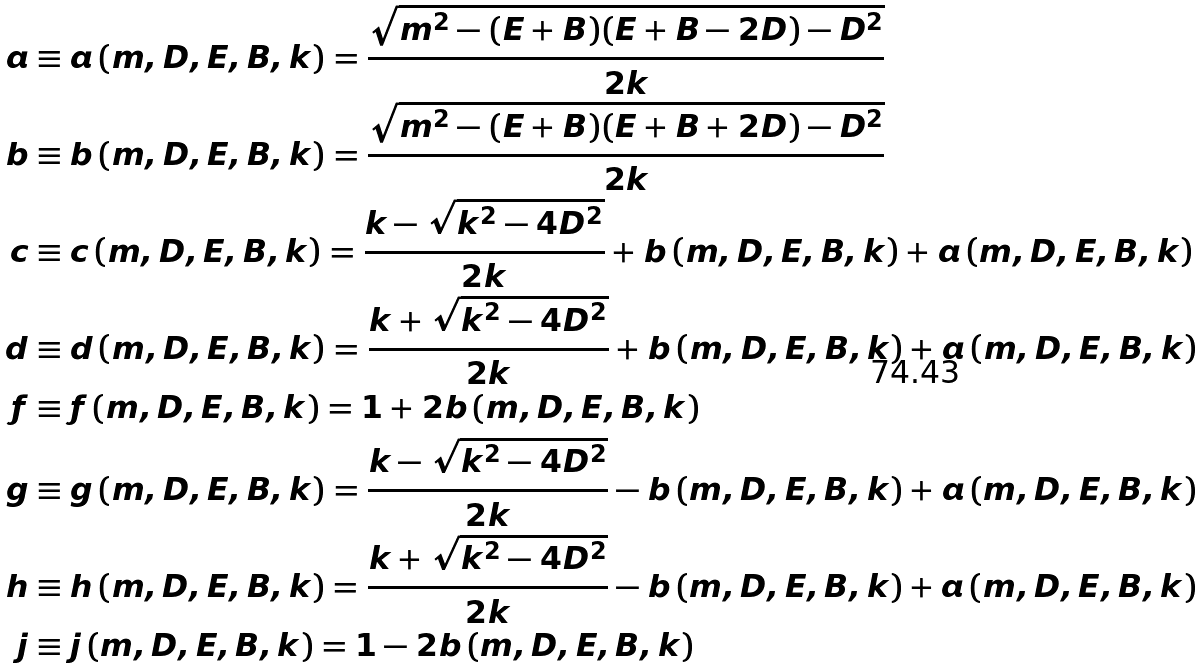<formula> <loc_0><loc_0><loc_500><loc_500>a & \equiv a \left ( m , D , E , B , k \right ) = \frac { \sqrt { m ^ { 2 } - ( E + B ) ( E + B - 2 D ) - D ^ { 2 } } } { 2 k } \\ b & \equiv b \left ( m , D , E , B , k \right ) = \frac { \sqrt { m ^ { 2 } - ( E + B ) ( E + B + 2 D ) - D ^ { 2 } } } { 2 k } \\ c & \equiv c \left ( m , D , E , B , k \right ) = \frac { k - \sqrt { k ^ { 2 } - 4 D ^ { 2 } } } { 2 k } + b \left ( m , D , E , B , k \right ) + a \left ( m , D , E , B , k \right ) \\ d & \equiv d \left ( m , D , E , B , k \right ) = \frac { k + \sqrt { k ^ { 2 } - 4 D ^ { 2 } } } { 2 k } + b \left ( m , D , E , B , k \right ) + a \left ( m , D , E , B , k \right ) \\ f & \equiv f \left ( m , D , E , B , k \right ) = 1 + 2 b \left ( m , D , E , B , k \right ) \\ g & \equiv g \left ( m , D , E , B , k \right ) = \frac { k - \sqrt { k ^ { 2 } - 4 D ^ { 2 } } } { 2 k } - b \left ( m , D , E , B , k \right ) + a \left ( m , D , E , B , k \right ) \\ h & \equiv h \left ( m , D , E , B , k \right ) = \frac { k + \sqrt { k ^ { 2 } - 4 D ^ { 2 } } } { 2 k } - b \left ( m , D , E , B , k \right ) + a \left ( m , D , E , B , k \right ) \\ j & \equiv j \left ( m , D , E , B , k \right ) = 1 - 2 b \left ( m , D , E , B , k \right )</formula> 